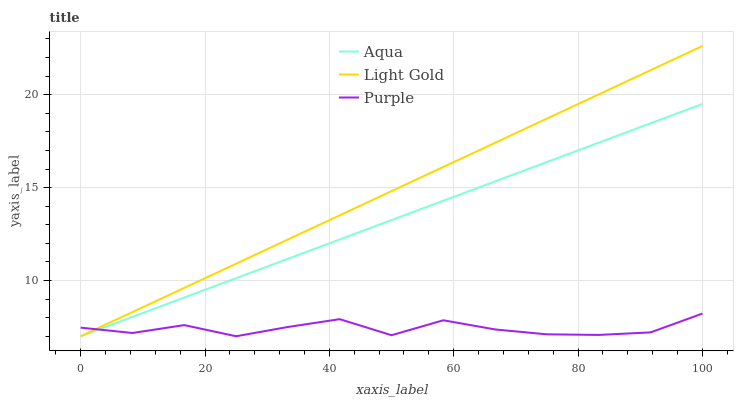Does Purple have the minimum area under the curve?
Answer yes or no. Yes. Does Light Gold have the maximum area under the curve?
Answer yes or no. Yes. Does Aqua have the minimum area under the curve?
Answer yes or no. No. Does Aqua have the maximum area under the curve?
Answer yes or no. No. Is Aqua the smoothest?
Answer yes or no. Yes. Is Purple the roughest?
Answer yes or no. Yes. Is Light Gold the smoothest?
Answer yes or no. No. Is Light Gold the roughest?
Answer yes or no. No. Does Purple have the lowest value?
Answer yes or no. Yes. Does Light Gold have the highest value?
Answer yes or no. Yes. Does Aqua have the highest value?
Answer yes or no. No. Does Aqua intersect Purple?
Answer yes or no. Yes. Is Aqua less than Purple?
Answer yes or no. No. Is Aqua greater than Purple?
Answer yes or no. No. 